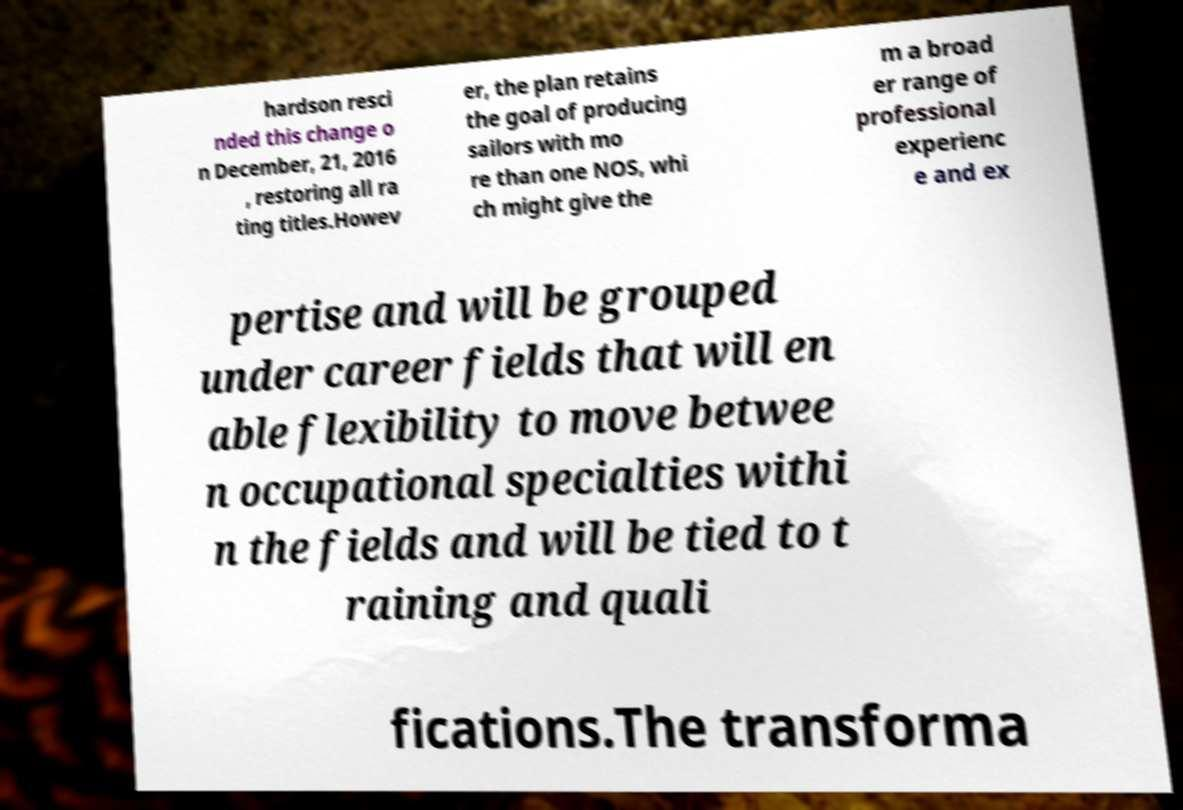For documentation purposes, I need the text within this image transcribed. Could you provide that? hardson resci nded this change o n December, 21, 2016 , restoring all ra ting titles.Howev er, the plan retains the goal of producing sailors with mo re than one NOS, whi ch might give the m a broad er range of professional experienc e and ex pertise and will be grouped under career fields that will en able flexibility to move betwee n occupational specialties withi n the fields and will be tied to t raining and quali fications.The transforma 